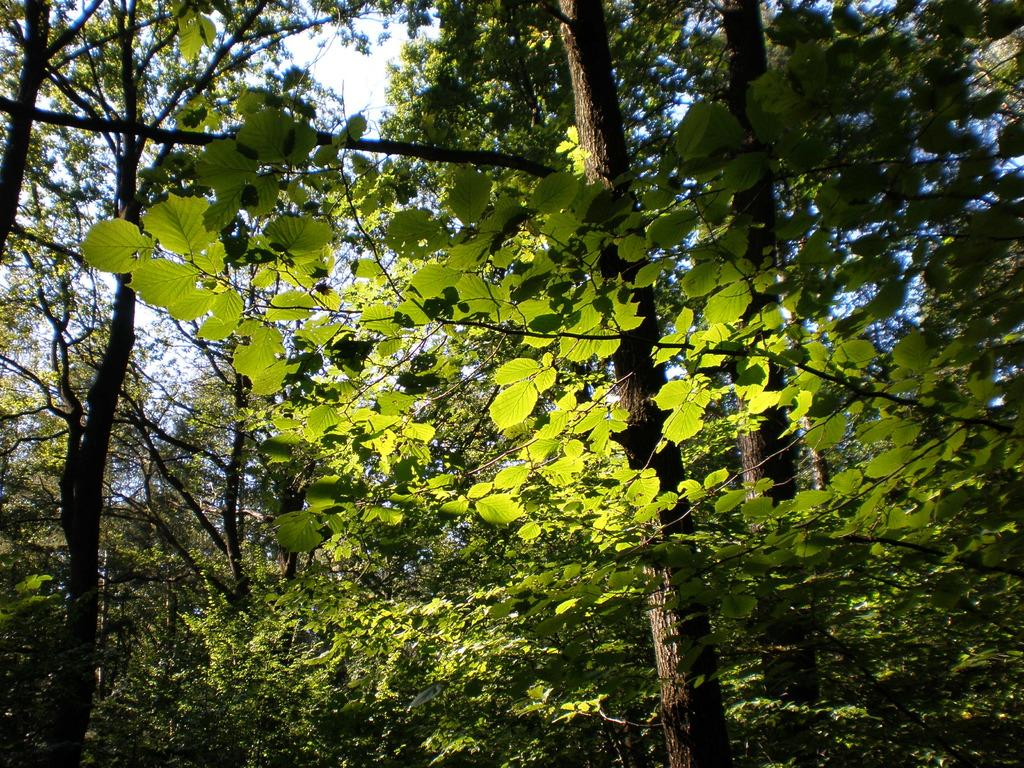What type of vegetation can be seen in the image? There are trees in the image. What part of the natural environment is visible in the image? The sky is visible in the background of the image. What is the name of the person who painted the trees in the image? There is no information about the artist who painted the trees in the image, and the image appears to be a photograph rather than a painting. 